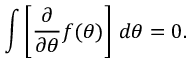<formula> <loc_0><loc_0><loc_500><loc_500>\int \left [ { \frac { \partial } { \partial \theta } } f ( \theta ) \right ] \, d \theta = 0 .</formula> 